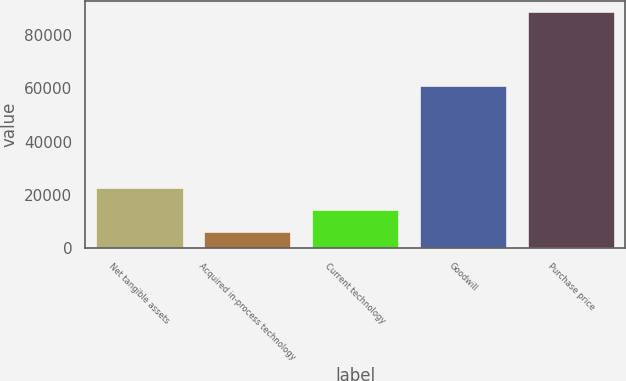Convert chart. <chart><loc_0><loc_0><loc_500><loc_500><bar_chart><fcel>Net tangible assets<fcel>Acquired in-process technology<fcel>Current technology<fcel>Goodwill<fcel>Purchase price<nl><fcel>22457.6<fcel>5953<fcel>14205.3<fcel>60794<fcel>88476<nl></chart> 